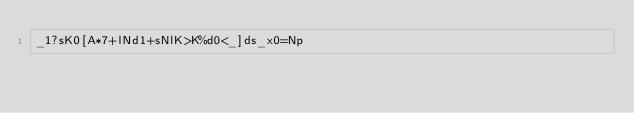Convert code to text. <code><loc_0><loc_0><loc_500><loc_500><_dc_>_1?sK0[A*7+lNd1+sNlK>K%d0<_]ds_x0=Np</code> 